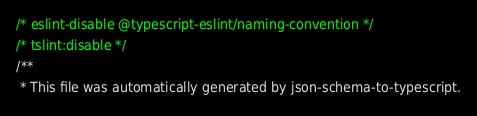<code> <loc_0><loc_0><loc_500><loc_500><_TypeScript_>/* eslint-disable @typescript-eslint/naming-convention */
/* tslint:disable */
/**
 * This file was automatically generated by json-schema-to-typescript.</code> 